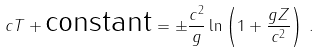<formula> <loc_0><loc_0><loc_500><loc_500>c T + \text {constant} = \pm \frac { c ^ { 2 } } { g } \ln \left ( 1 + \frac { g Z } { c ^ { 2 } } \right ) \, .</formula> 